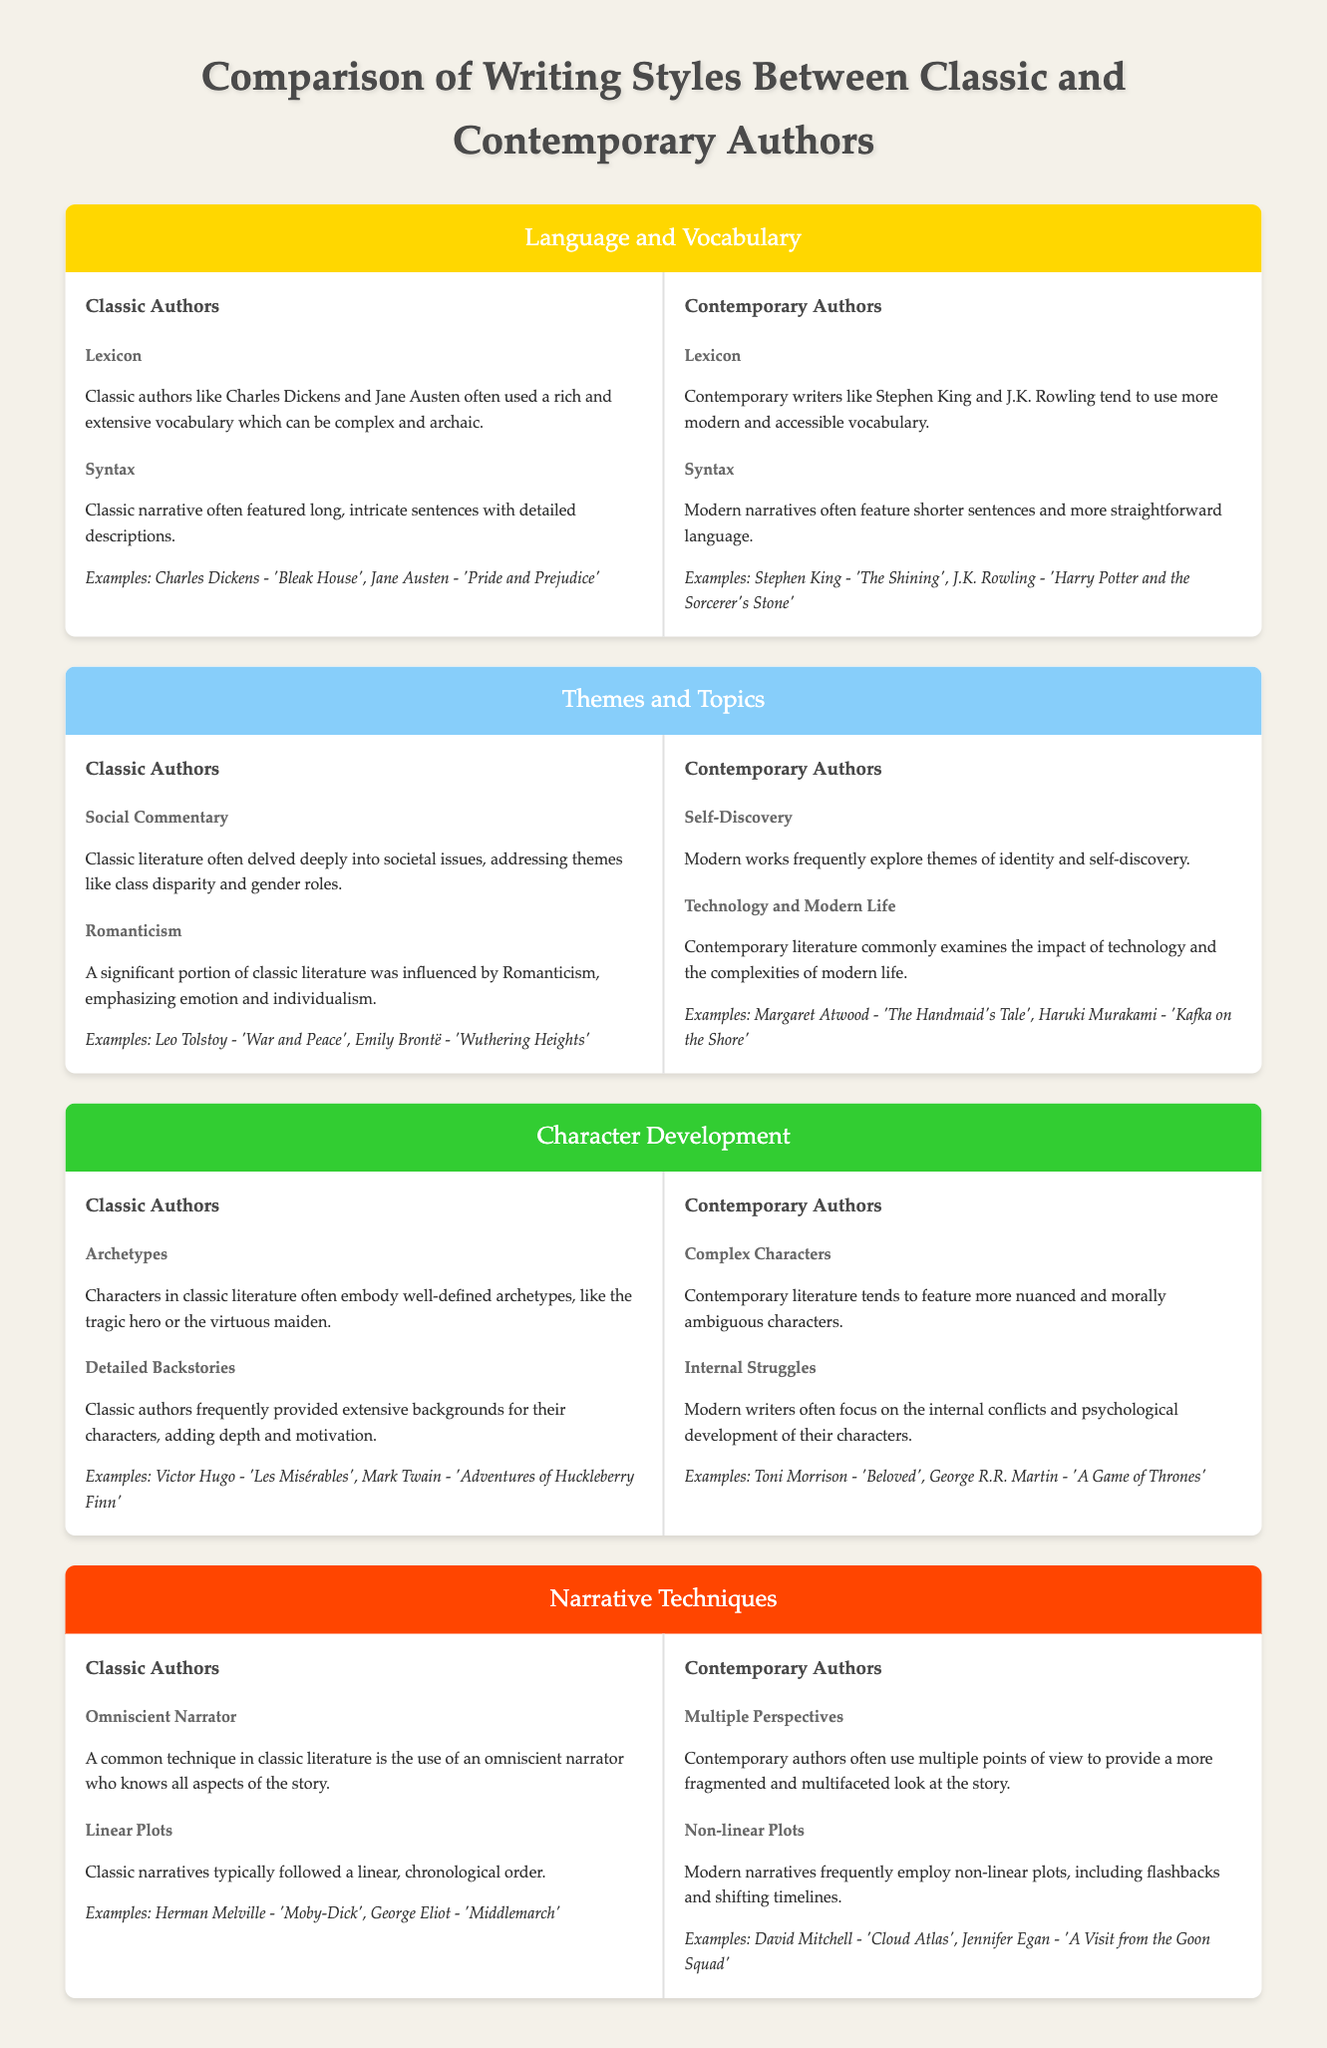What themes did classic authors often explore? Classic authors often explored social commentary and romanticism as major themes in their works, addressing class disparity and individual emotions.
Answer: Social Commentary, Romanticism Which contemporary author is known for writing about identity and self-discovery? Contemporary authors frequently explore themes of identity and self-discovery, with writers like Margaret Atwood exemplifying this focus in her work.
Answer: Margaret Atwood What kind of narrator is commonly used in classic literature? Classic literature typically features an omniscient narrator who knows all aspects of the story, enabling readers to understand the entire narrative.
Answer: Omniscient Narrator How did classic authors generally develop their characters? Classic authors often provided extensive backstories for their characters, giving them depth and motivation through detailed background information.
Answer: Detailed Backstories What narrative structure is common in contemporary writing? Contemporary writing frequently employs non-linear plots, which may include techniques such as flashbacks and shifting timelines to enhance storytelling.
Answer: Non-linear Plots Which author wrote 'The Handmaid's Tale'? 'The Handmaid's Tale' is a notable work authored by Margaret Atwood, showcasing themes relevant to contemporary literature.
Answer: Margaret Atwood What is a key characteristic of characters in contemporary literature? Contemporary literature tends to feature more nuanced and morally ambiguous characters, reflecting modern complexities and internal struggles.
Answer: Complex Characters What kind of vocabulary is used by classic authors? Classic authors typically used a rich and extensive vocabulary that can be complex and archaic, enhancing their interactive language.
Answer: Rich and Extensive Vocabulary What type of plots do classic authors typically follow? Classic narratives typically followed a linear, chronological order, maintaining a straightforward progression in the storyline.
Answer: Linear Plots 